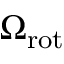<formula> <loc_0><loc_0><loc_500><loc_500>\Omega _ { r o t }</formula> 